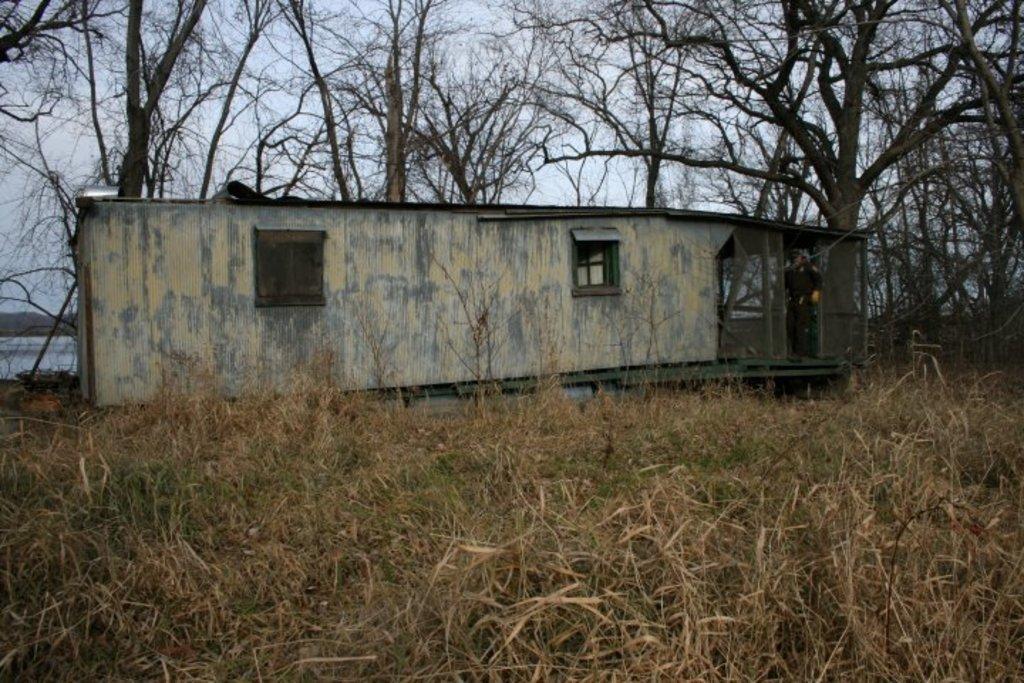In one or two sentences, can you explain what this image depicts? In this image we can see a house, inside the house, we can see a person standing and holding an object, there are some trees, water, grass and mountains, in the background, we can see the sky. 